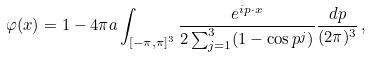Convert formula to latex. <formula><loc_0><loc_0><loc_500><loc_500>\varphi ( x ) = 1 - 4 \pi a \int _ { [ - \pi , \pi ] ^ { 3 } } \frac { e ^ { i p \cdot x } } { 2 \sum _ { j = 1 } ^ { 3 } ( 1 - \cos p ^ { j } ) } \frac { d p } { ( 2 \pi ) ^ { 3 } } \, ,</formula> 